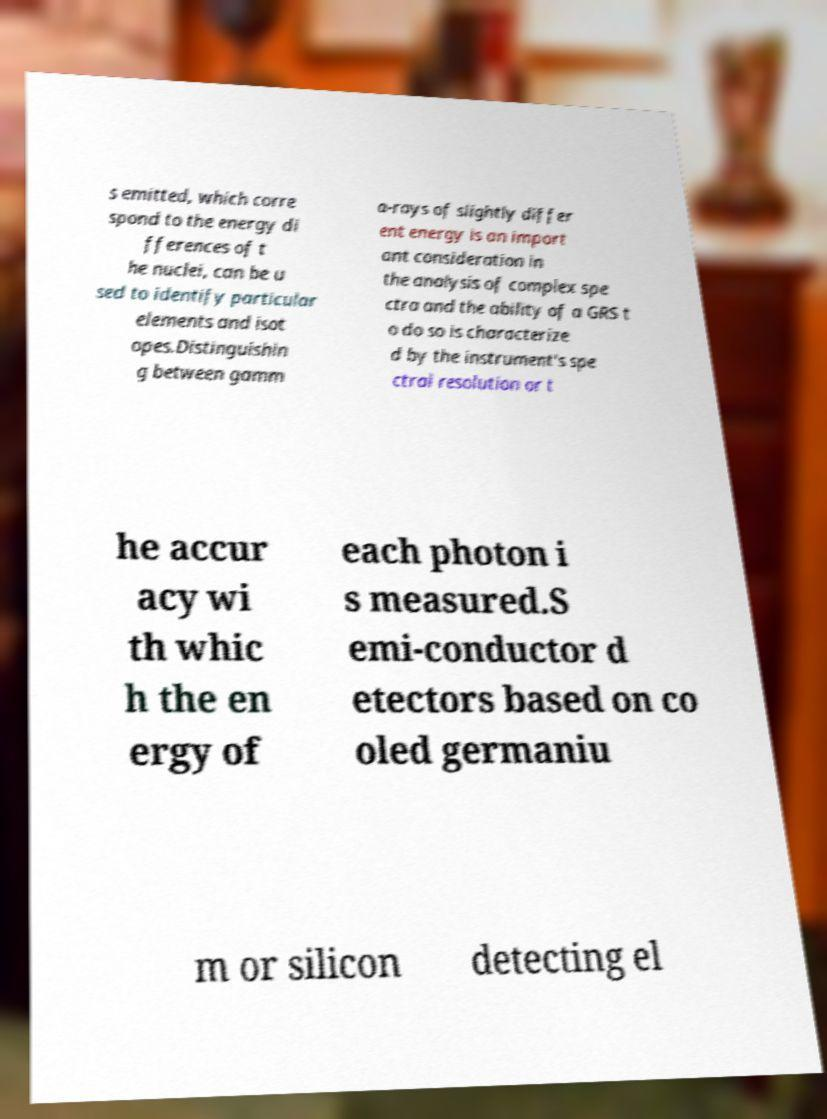Can you accurately transcribe the text from the provided image for me? s emitted, which corre spond to the energy di fferences of t he nuclei, can be u sed to identify particular elements and isot opes.Distinguishin g between gamm a-rays of slightly differ ent energy is an import ant consideration in the analysis of complex spe ctra and the ability of a GRS t o do so is characterize d by the instrument's spe ctral resolution or t he accur acy wi th whic h the en ergy of each photon i s measured.S emi-conductor d etectors based on co oled germaniu m or silicon detecting el 